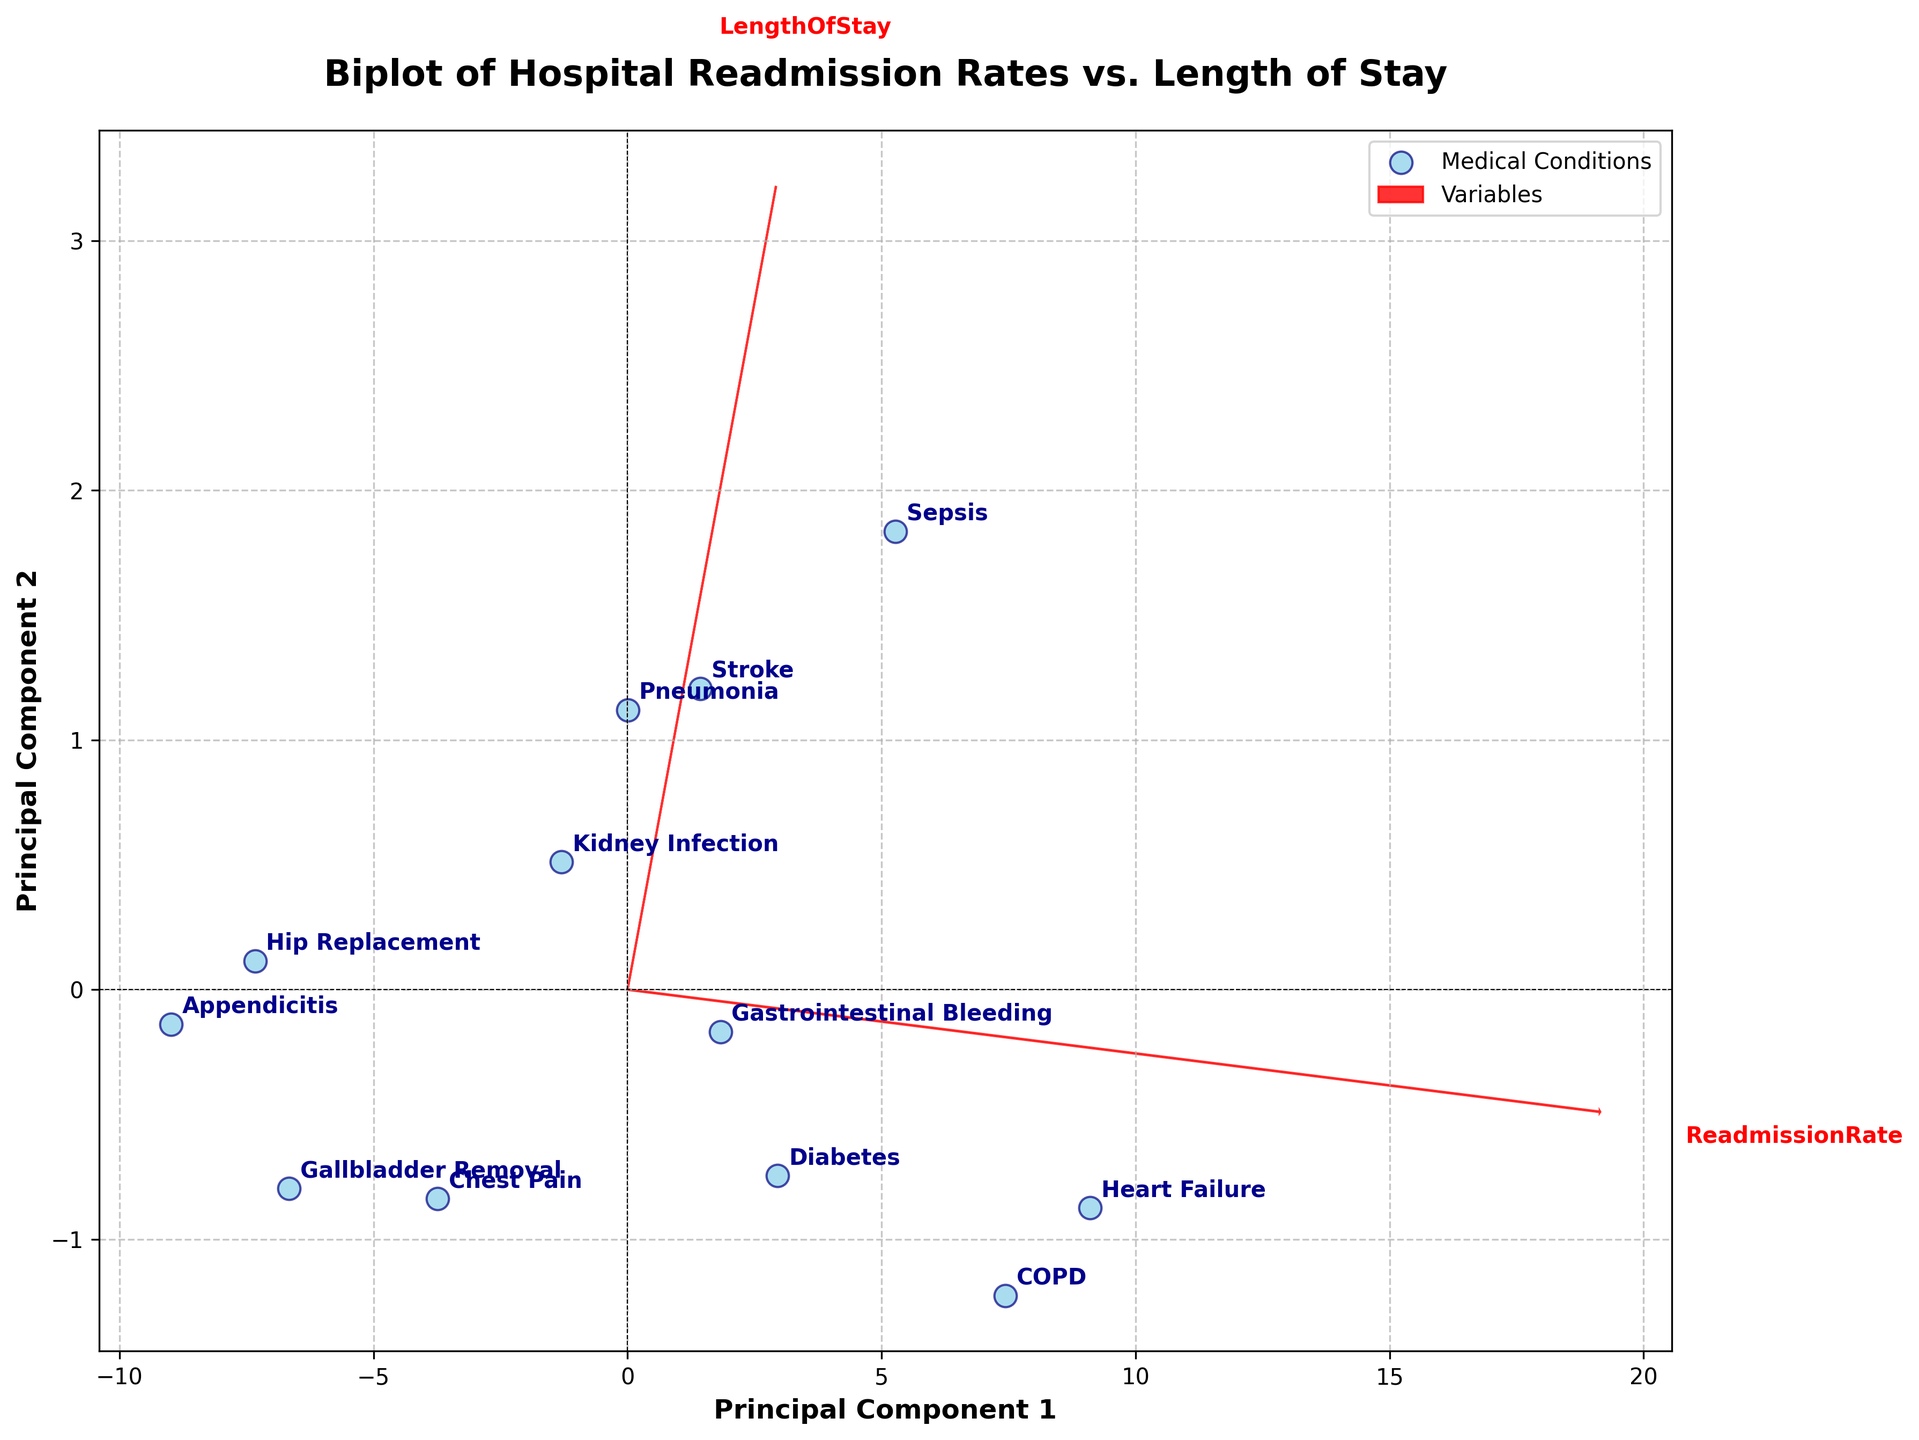What's the title of the plot? The title is provided at the top center of the figure. It aims to give an overview of what the plot represents.
Answer: Biplot of Hospital Readmission Rates vs. Length of Stay How many medical conditions are represented in the plot? Each point on the plot corresponds to a medical condition. By counting these points, we can determine the number of conditions represented.
Answer: 12 What medical condition has the highest readmission rate? The condition with the highest readmission rate is the one farthest to the right along the 'ReadmissionRate' loading vector.
Answer: Heart Failure Which medical condition has the shortest length of stay? The condition with the shortest length of stay would be the one positioned lowest along the 'LengthOfStay' loading vector.
Answer: Gallbladder Removal Are there more conditions with a higher readmission rate but shorter length of stay or vice versa? By visually inspecting the plot, count the number of conditions in each quadrant formed by intersection of the average lines of both components.
Answer: More conditions have a higher readmission rate but shorter length of stay What's the most common range for the length of stay among the conditions? By observing the spread of points along the 'LengthOfStay' axis, we identify where most points cluster.
Answer: 2.4 to 5.6 days How are the variables 'ReadmissionRate' and 'LengthOfStay' visually represented in the plot? The axes 'ReadmissionRate' and 'LengthOfStay' are represented as vectors (arrows), indicating their direction and contribution.
Answer: As red arrows Which condition is closest to the origin of the principal component axes? The condition nearest the plot's origin is the one closest to (0, 0) in the transformed score space.
Answer: Gallbladder Removal How does the length of stay for 'Stroke' compare with 'Pneumonia'? Identify their positions along the 'LengthOfStay' vector and compare.
Answer: Stroke has a longer length of stay than Pneumonia What’s the relationship between 'ReadmissionRate' and 'LengthOfStay' based on the plot? By examining the angle between the vectors of 'ReadmissionRate' and 'LengthOfStay', we determine whether they are related or orthogonal.
Answer: Positively related, though not strongly 